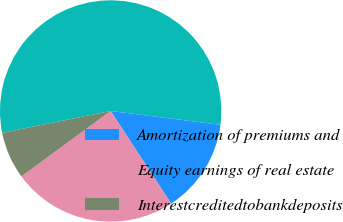Convert chart to OTSL. <chart><loc_0><loc_0><loc_500><loc_500><pie_chart><ecel><fcel>Amortization of premiums and<fcel>Equity earnings of real estate<fcel>Interestcreditedtobankdeposits<nl><fcel>55.16%<fcel>13.8%<fcel>24.14%<fcel>6.9%<nl></chart> 